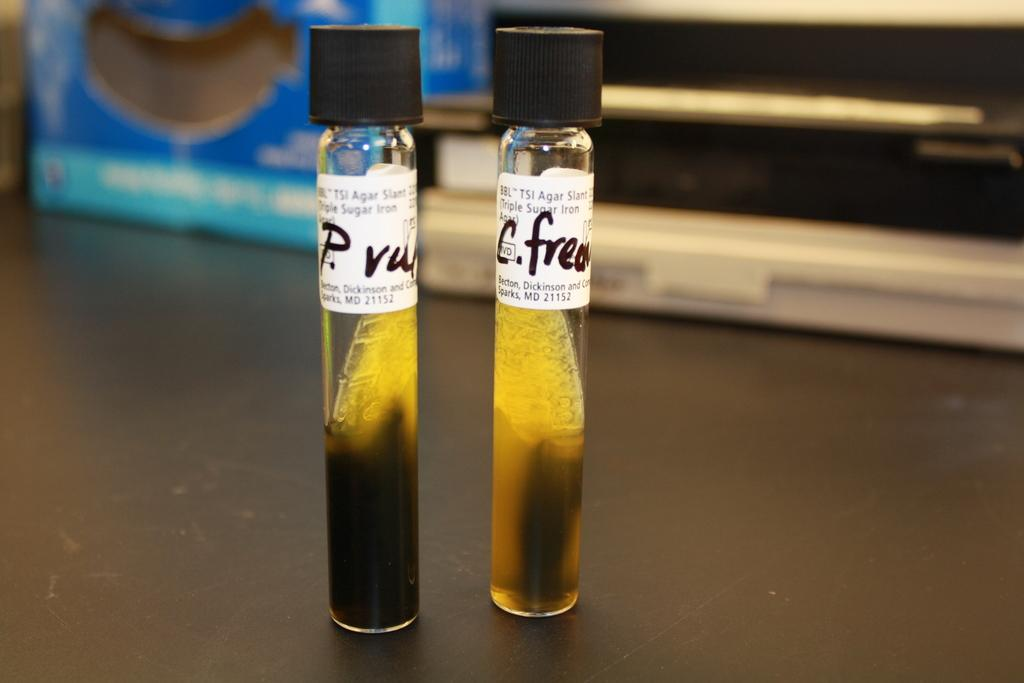Provide a one-sentence caption for the provided image. two vials full of murky ingredients labeled TSI Agar Slant. 